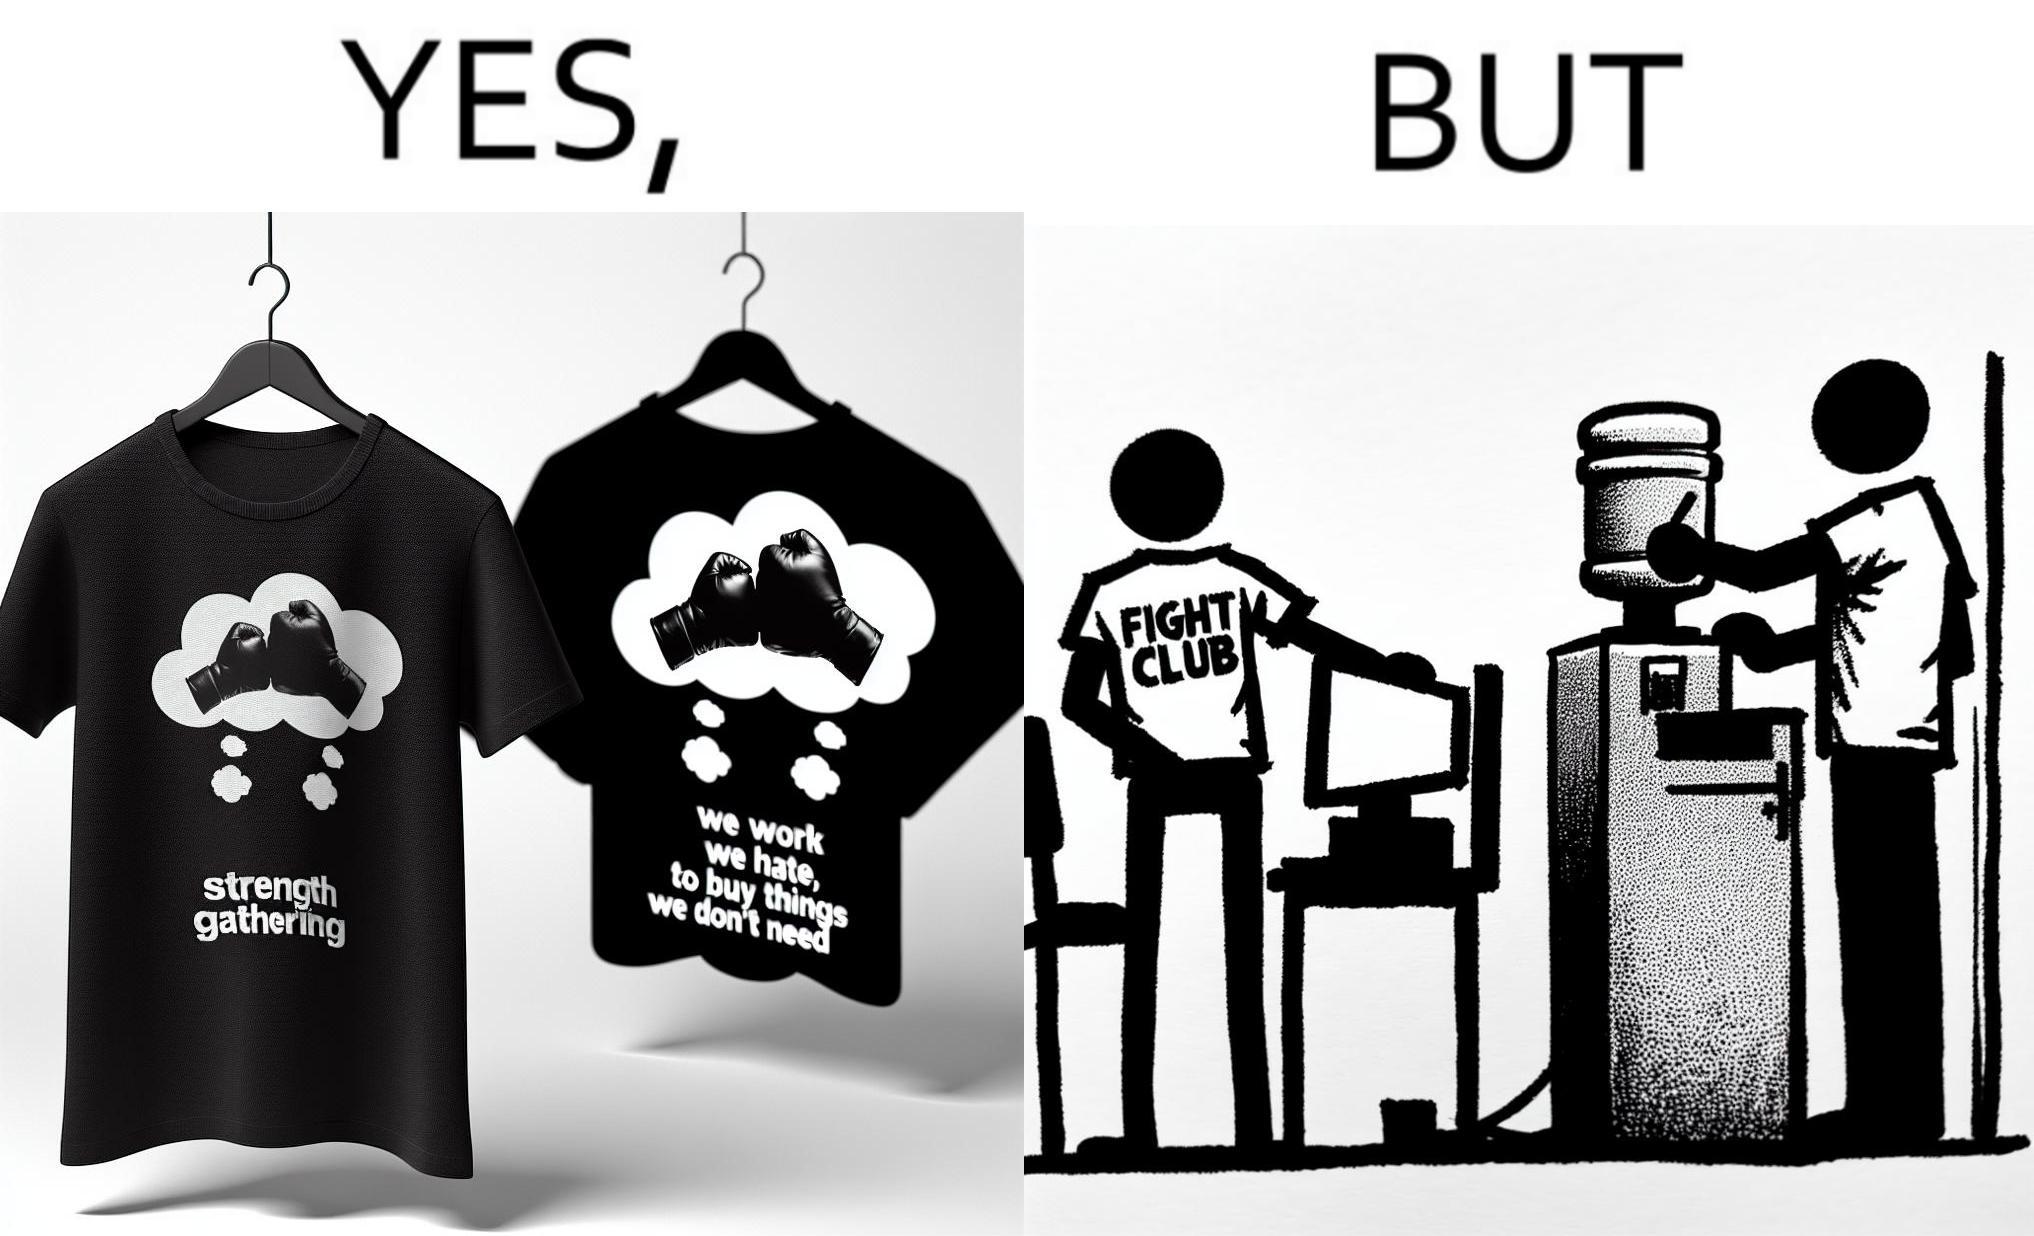Does this image contain satire or humor? Yes, this image is satirical. 